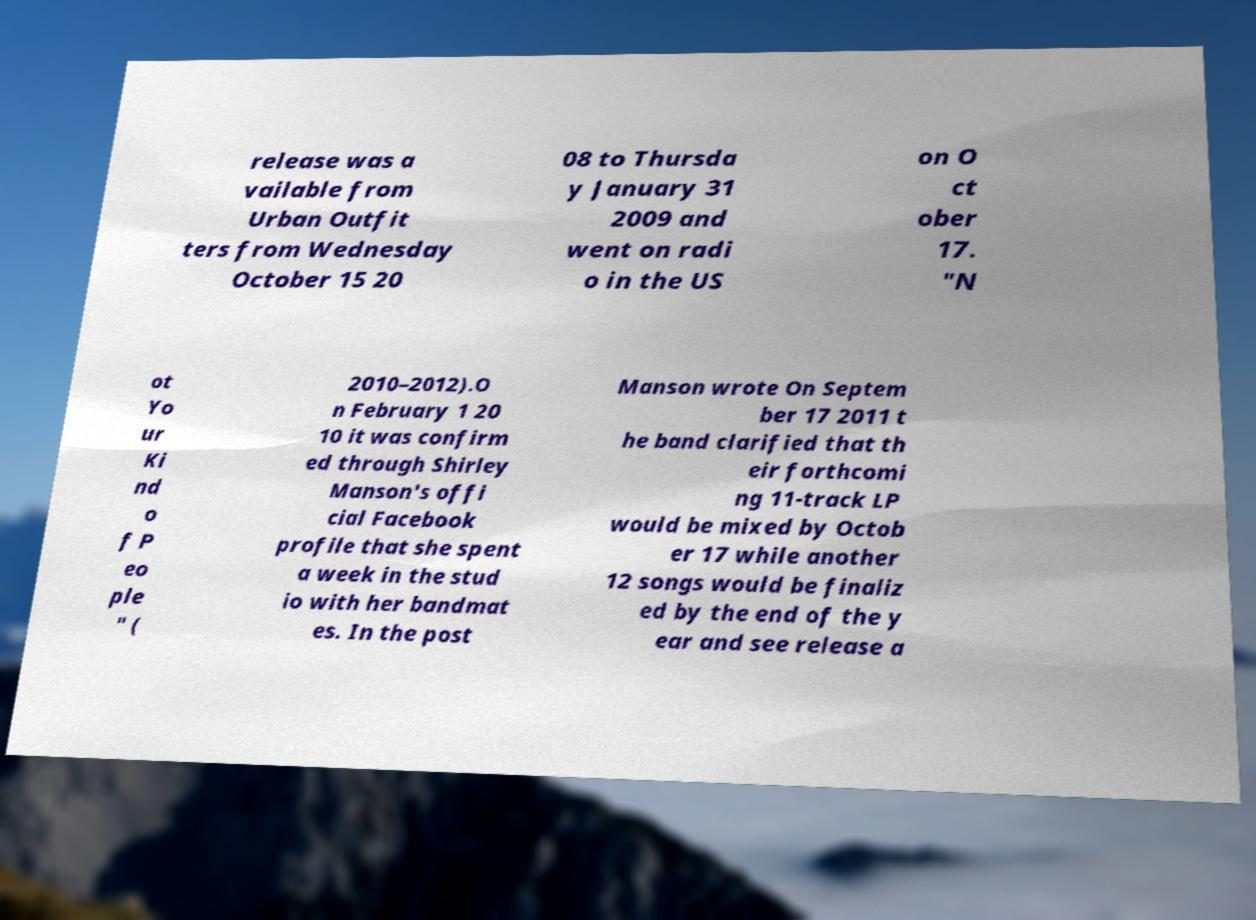There's text embedded in this image that I need extracted. Can you transcribe it verbatim? release was a vailable from Urban Outfit ters from Wednesday October 15 20 08 to Thursda y January 31 2009 and went on radi o in the US on O ct ober 17. "N ot Yo ur Ki nd o f P eo ple " ( 2010–2012).O n February 1 20 10 it was confirm ed through Shirley Manson's offi cial Facebook profile that she spent a week in the stud io with her bandmat es. In the post Manson wrote On Septem ber 17 2011 t he band clarified that th eir forthcomi ng 11-track LP would be mixed by Octob er 17 while another 12 songs would be finaliz ed by the end of the y ear and see release a 